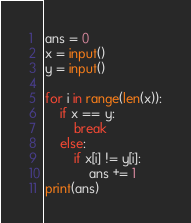Convert code to text. <code><loc_0><loc_0><loc_500><loc_500><_Python_>ans = 0
x = input()
y = input()

for i in range(len(x)):
    if x == y:
        break
    else:
        if x[i] != y[i]:
            ans += 1
print(ans)</code> 